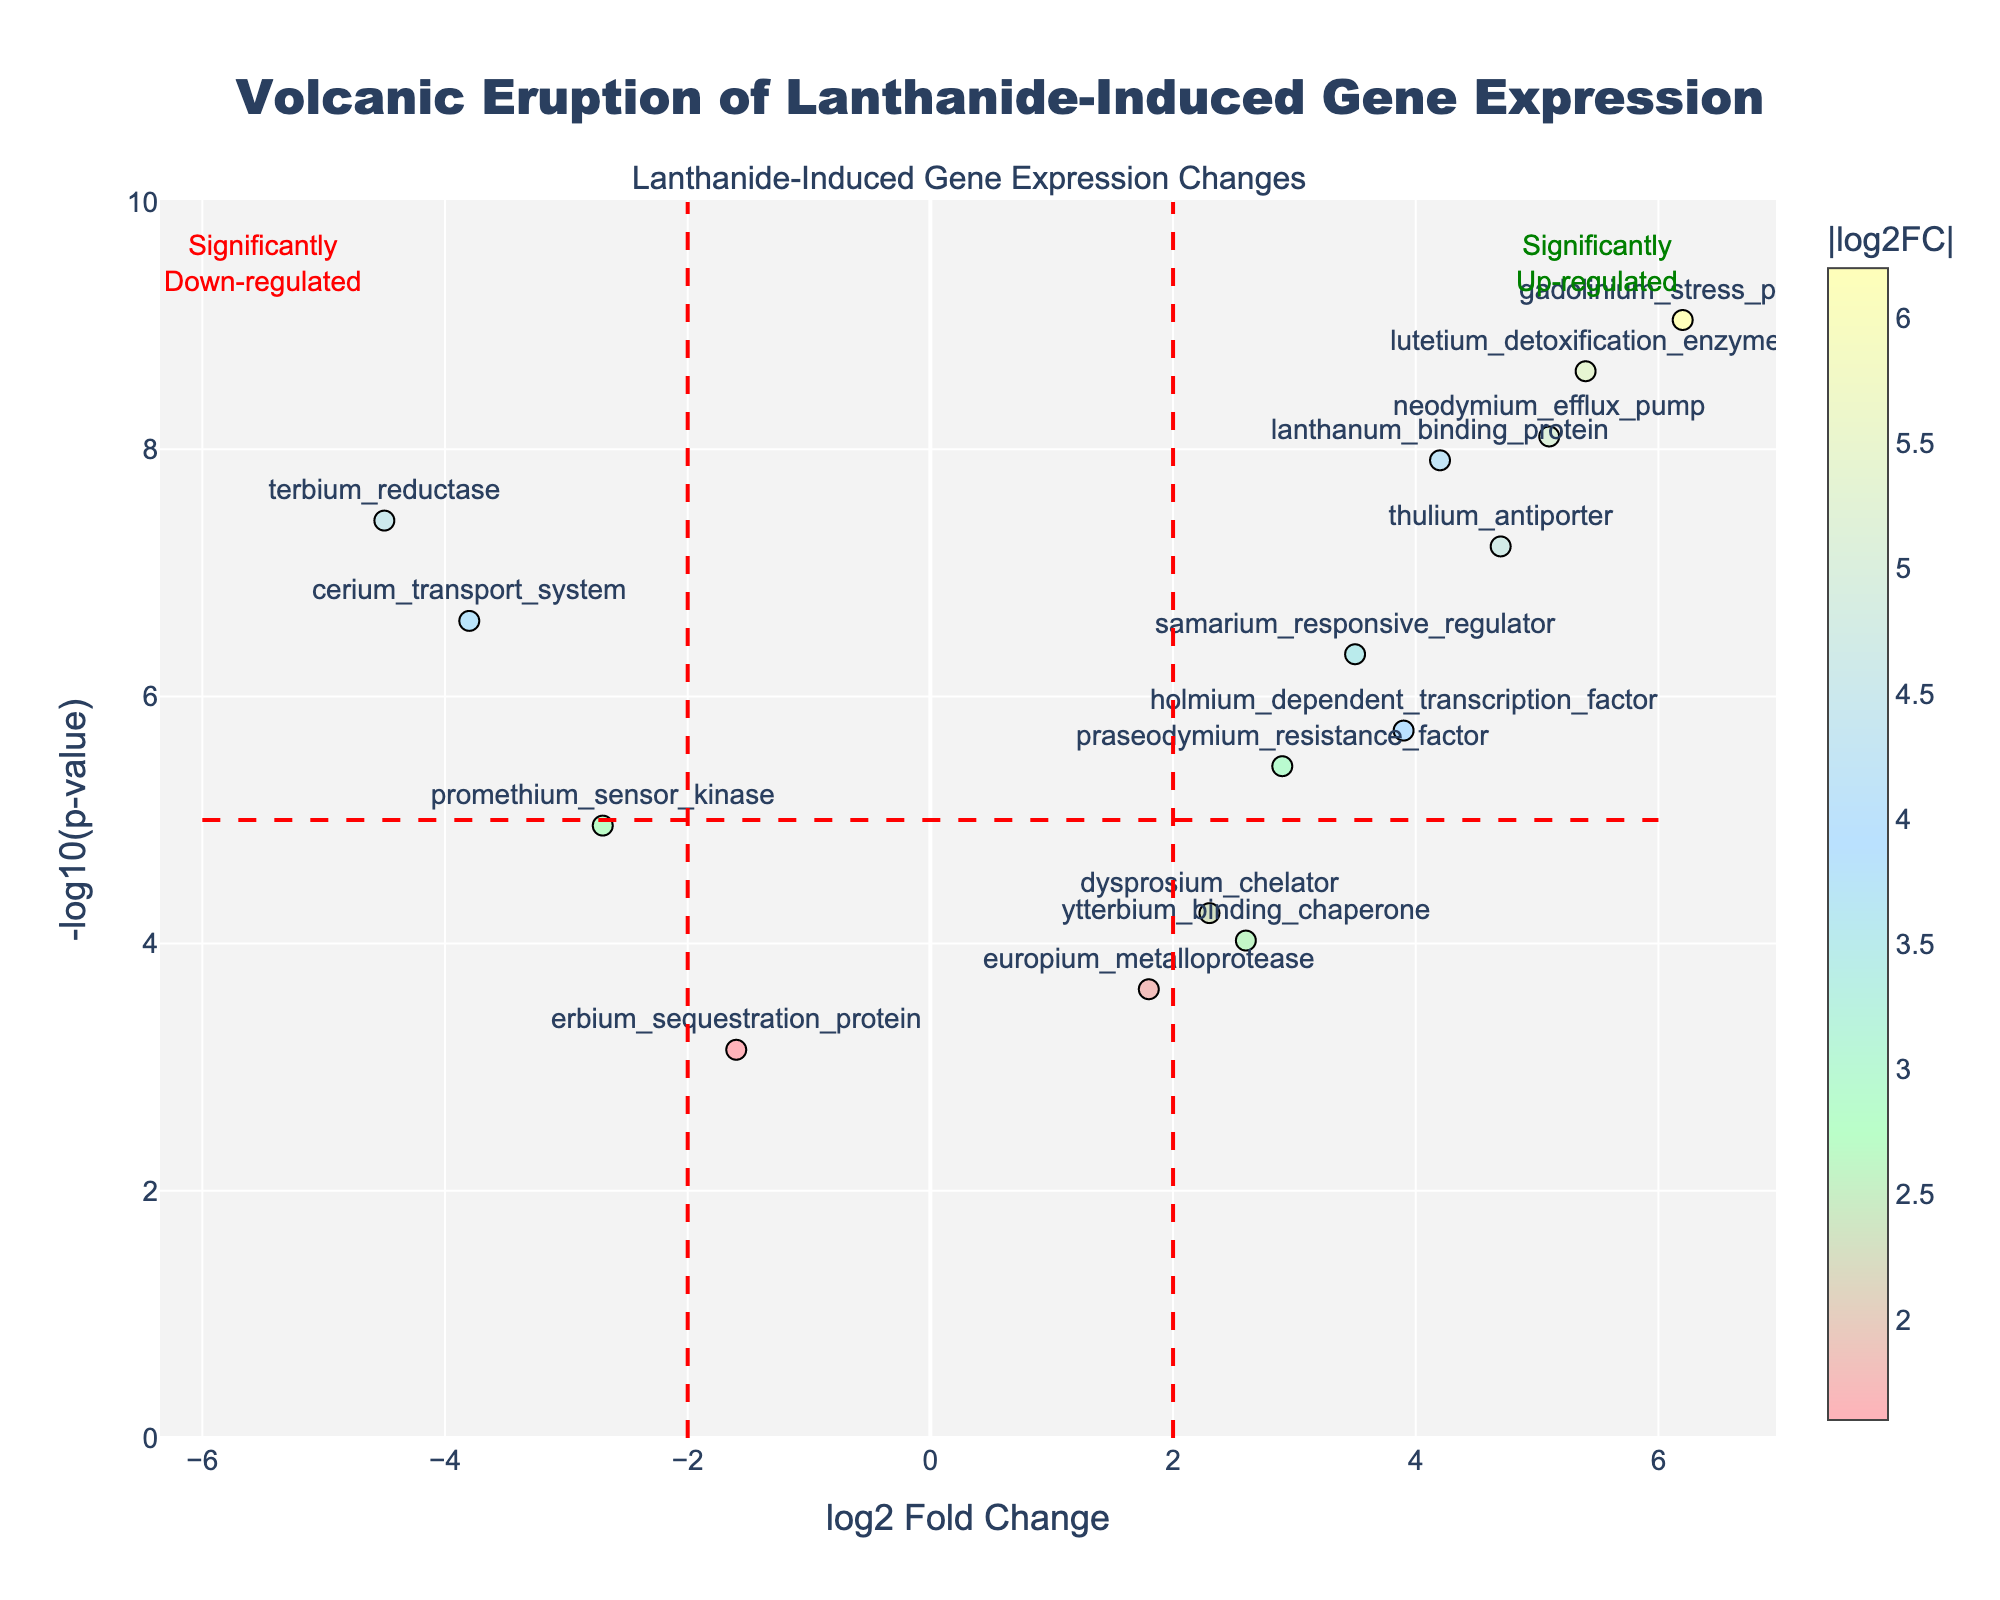How many genes are significantly up-regulated? To determine the number of genes that are significantly up-regulated, we look for points on the right side of the vertical line at log2 Fold Change = 2 and above the horizontal line at -log10(p-value) = 5. Count the genes fulfilling these criteria: neodymium_efflux_pump, gadolinium_stress_protein, thulium_antiporter, lutetium_detoxification_enzyme, lanthanum_binding_protein.
Answer: 5 What is the title of the plot? The title of the plot is prominently displayed at the top of the graph and typically describes the visualized data.
Answer: Volcanic Eruption of Lanthanide-Induced Gene Expression Which gene has the highest log2 Fold Change value? To find the gene with the highest log2 Fold Change value, look at the x-axis and identify the rightmost point. This point corresponds to the gene gadolinium_stress_protein.
Answer: gadolinium_stress_protein Which gene exhibits the lowest p-value? To identify the gene with the lowest p-value, find the point highest on the y-axis. This point corresponds to the gene gadolinium_stress_protein.
Answer: gadolinium_stress_protein What is the y-axis label in the plot? The y-axis label is used to describe what the y-axis represents. It can be found along the side of the y-axis.
Answer: -log10(p-value) Which gene is most significantly down-regulated? To find the most significantly down-regulated gene, look at the points on the left side of the vertical line at log2 Fold Change = -2 and above the horizontal line at -log10(p-value) = 5, and identify the lowest x-axis value. The gene terbium_reductase meets these criteria.
Answer: terbium_reductase What is the log2 Fold Change value of dysprosium_chelator? Locate the point labeled "dysprosium_chelator" and note its position on the x-axis, which represents the log2 Fold Change value.
Answer: 2.3 Which two genes are closest in log2 Fold Change but have opposite regulation (one up, one down)? Identify genes close to zero on the x-axis but on opposite sides. The genes erbium_sequestration_protein (-1.6) and europium_metalloprotease (1.8) are closest with one being down-regulated and the other up-regulated.
Answer: erbium_sequestration_protein and europium_metalloprotease What does the red dashed line at -log10(p-value) = 5 signify? The red dashed lines are threshold markers; the one at -log10(p-value) = 5 indicates the significance cutoff. Genes above this line are considered significantly differentially expressed.
Answer: Significance cutoff How many genes have a log2 Fold Change greater than 3? Count the number of genes to the right of the vertical line at log2 Fold Change = 3. These genes include lanthanum_binding_protein, neodymium_efflux_pump, gadolinium_stress_protein, thulium_antiporter, samarium_responsive_regulator, holmium_dependent_transcription_factor.
Answer: 6 